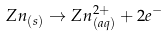<formula> <loc_0><loc_0><loc_500><loc_500>Z n _ { ( s ) } \rightarrow Z n _ { ( a q ) } ^ { 2 + } + 2 e ^ { - } \</formula> 